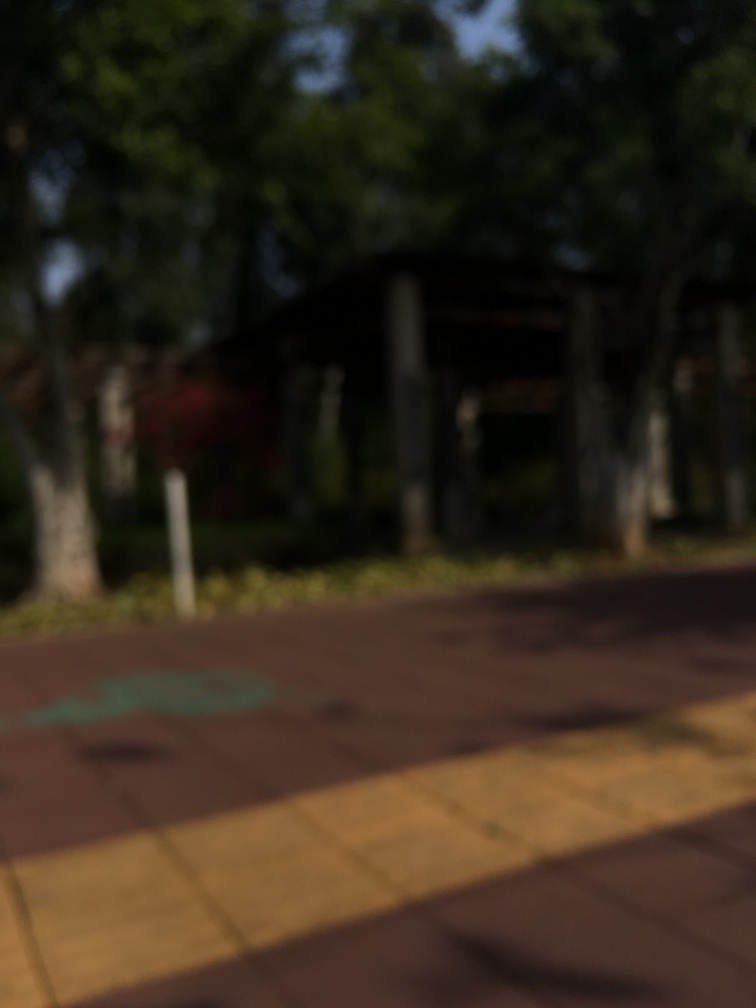Is the image clear and well focused? Upon examination, the image is indeed out of focus, as it lacks sharpness and detail. The blurriness obscures the specifics of the scene, which seems to include trees and a structure, potentially an outdoor setting such as a park or garden area. 